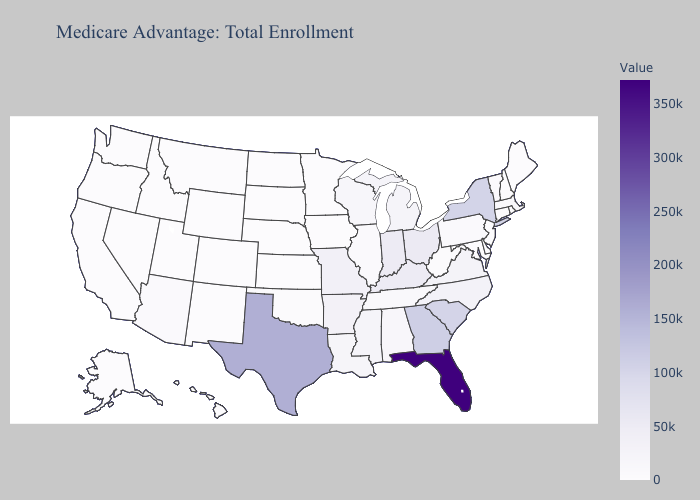Does Missouri have the highest value in the MidWest?
Keep it brief. No. Does West Virginia have the highest value in the South?
Quick response, please. No. Does the map have missing data?
Answer briefly. No. Which states hav the highest value in the West?
Be succinct. Arizona. 